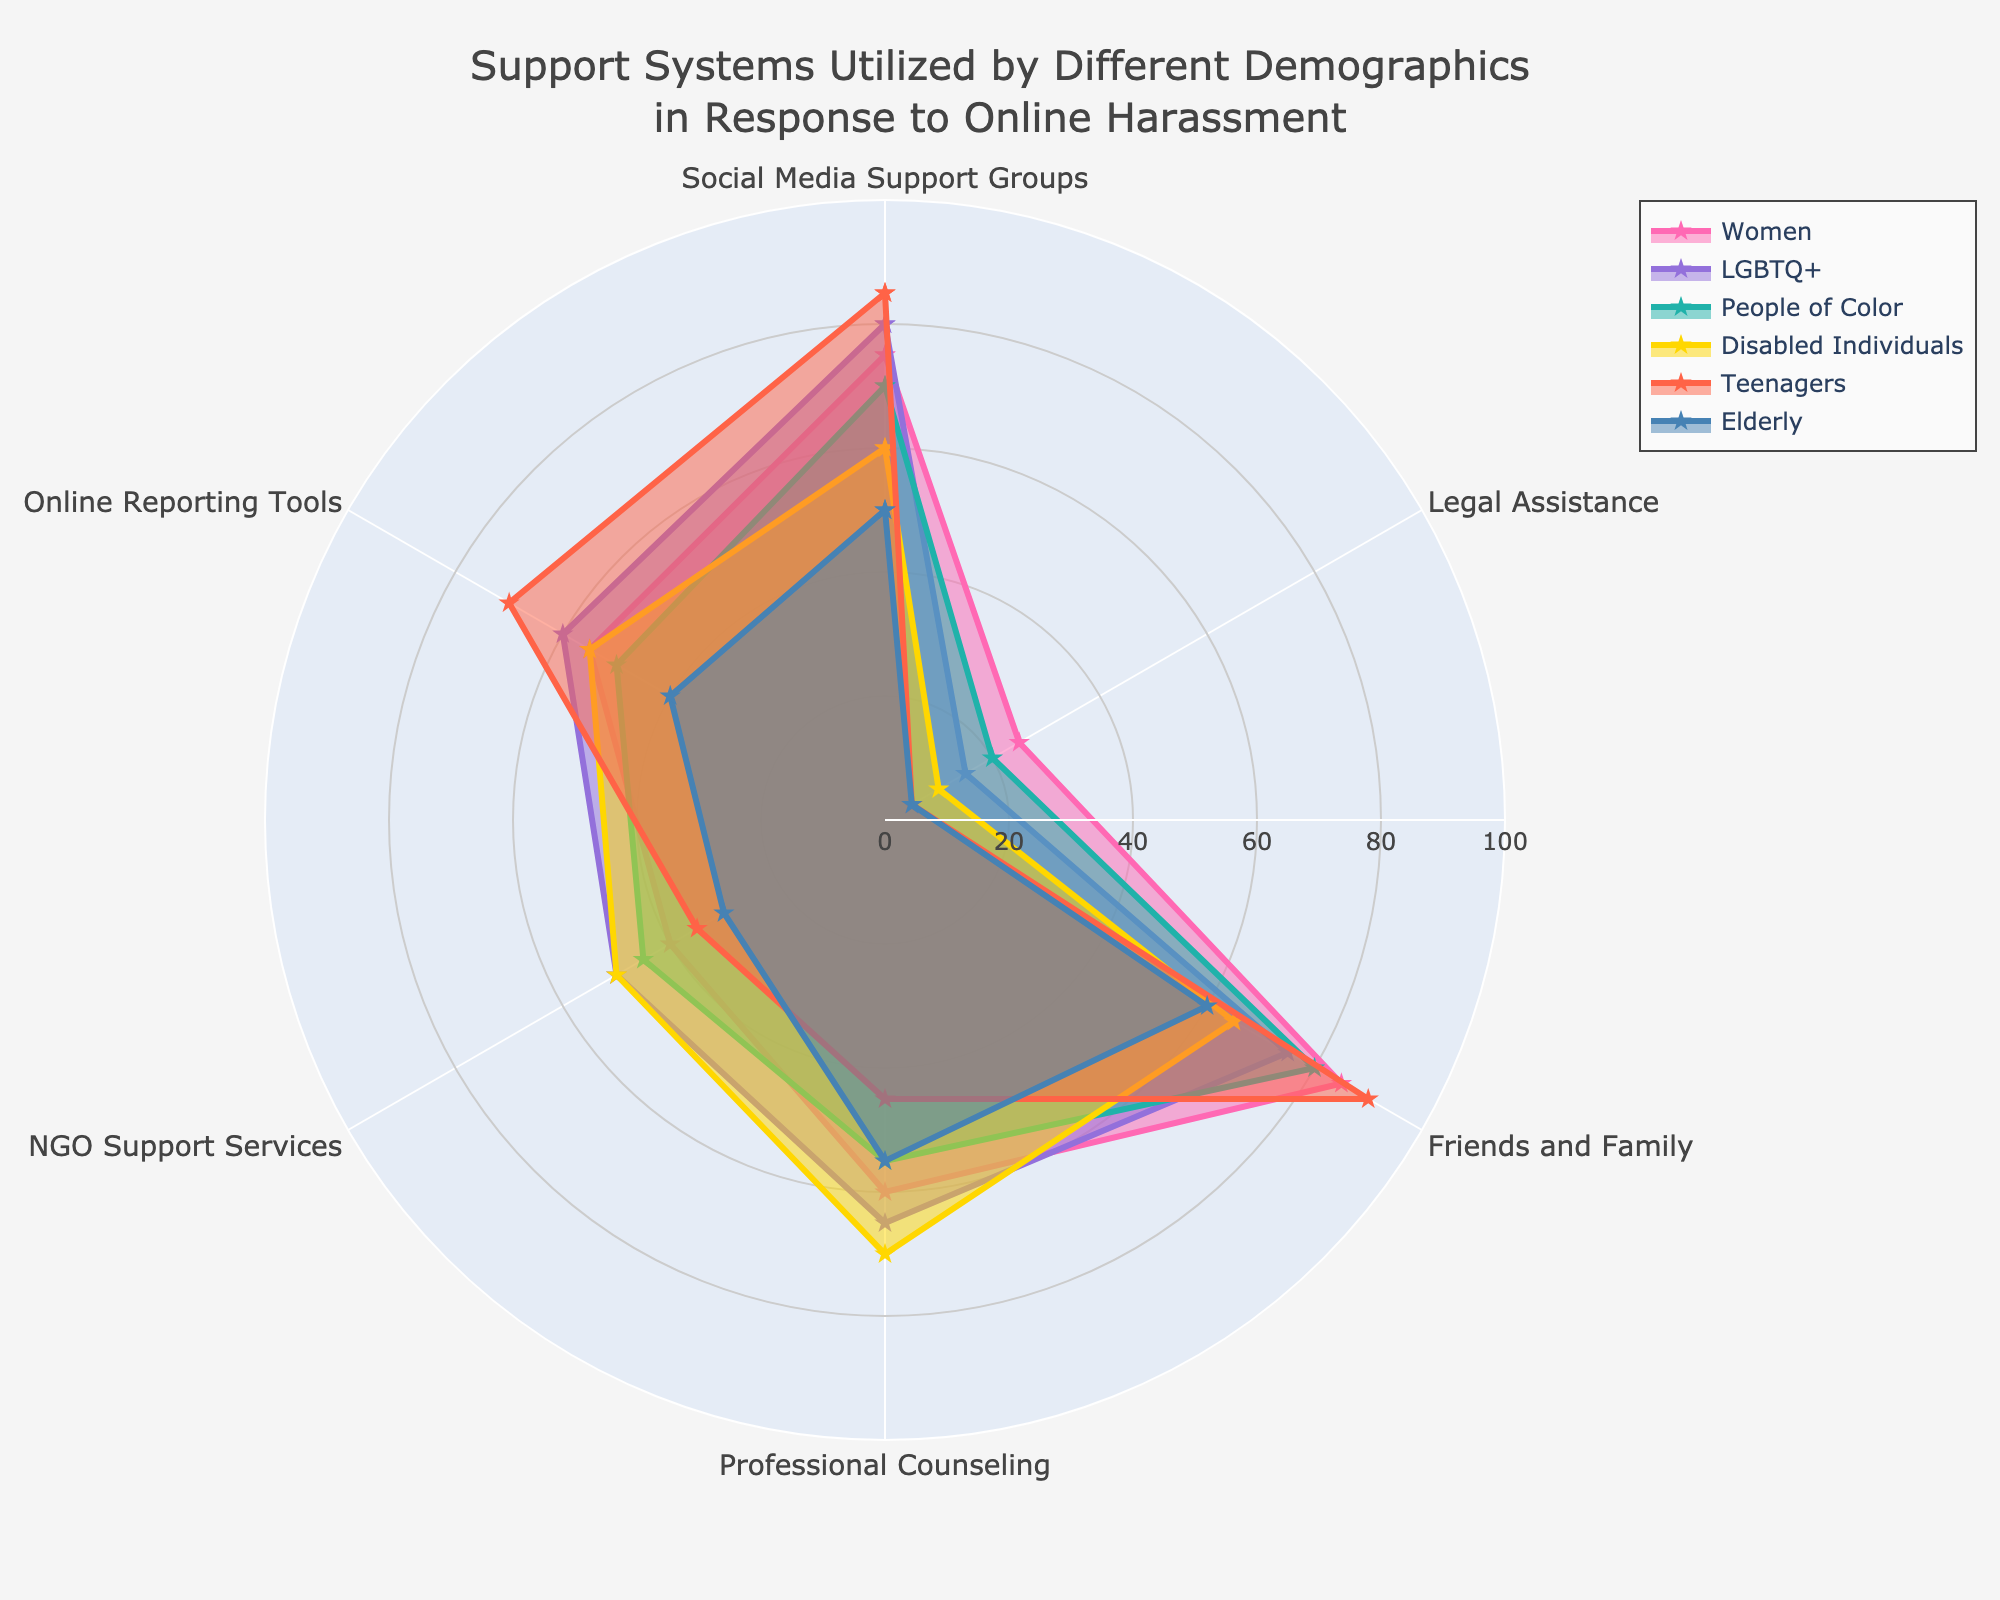What does the radar chart title indicate? The title of the radar chart provides an overview of the subject matter, which is "Support Systems Utilized by Different Demographics in Response to Online Harassment." This implies the chart displays data on how different demographic groups use various support systems to cope with online harassment.
Answer: Support Systems Utilized by Different Demographics in Response to Online Harassment Which demographic group perceives the highest support from 'Friends and Family'? By looking at the data points on 'Friends and Family,' the values for each demographic can be seen. The 'Teenagers' group shows the highest value, with 90.
Answer: Teenagers What are the two highest support systems utilized by the LGBTQ+ community? The radar chart shows different values for each support system used by the LGBTQ+ community. The highest values for this group are 'Social Media Support Groups' (80) and 'Professional Counseling' (65).
Answer: Social Media Support Groups and Professional Counseling Which demographic utilizes 'Legal Assistance' the least, and what is the value? By comparing the values for 'Legal Assistance' among all demographics, the 'Teenagers' and 'Elderly' groups both utilize it the least with a value of 5.
Answer: Teenagers and Elderly, 5 How does the use of 'Online Reporting Tools' compare between Women and Disabled Individuals? To compare the use of 'Online Reporting Tools,' we look at the values for Women (55) and Disabled Individuals (55), which are equal.
Answer: Equal (55) What is the average utilization rate of 'NGO Support Services' across all demographics? Sum the 'NGO Support Services' values across all demographics (40 + 50 + 45 + 50 + 35 + 30 = 250), then divide by 6 (the number of demographics): 250 / 6 = 41.67.
Answer: 41.67 Which group relies more on 'Professional Counseling' compared to 'Friends and Family'? Comparing each demographic’s values for 'Professional Counseling' and 'Friends and Family,' 'Disabled Individuals' rely more on 'Professional Counseling' (70) compared to 'Friends and Family' (65).
Answer: Disabled Individuals What is the median value of 'Social Media Support Groups' utilization? To find the median, list the 'Social Media Support Groups' values in order: 50, 60, 70, 75, 80, 85. The median is the average of the two middle numbers: (70 + 75) / 2 = 72.5.
Answer: 72.5 Which demographic has the most balanced utilization of the support systems (i.e., least variance in values)? By visually assessing the spread of the values in the radar chart, the 'Women' group has the most balanced utilization of support systems with values closer together (75, 25, 85, 60, 40, 55).
Answer: Women 